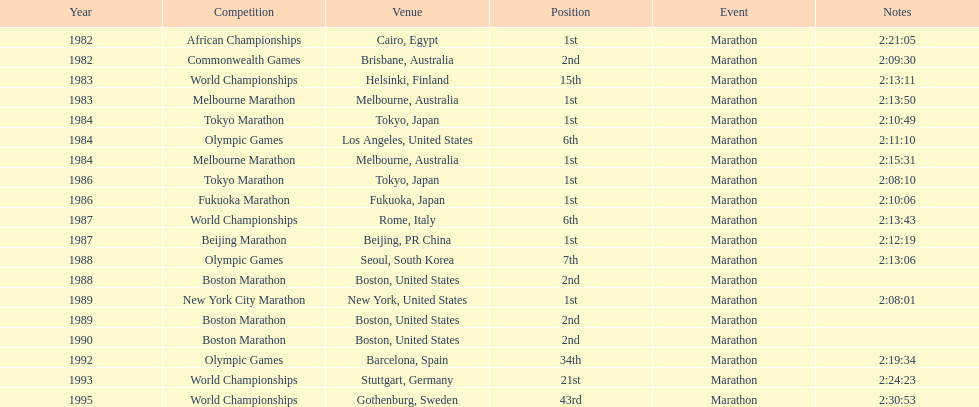Which competition is listed the most in this chart? World Championships. Could you parse the entire table? {'header': ['Year', 'Competition', 'Venue', 'Position', 'Event', 'Notes'], 'rows': [['1982', 'African Championships', 'Cairo, Egypt', '1st', 'Marathon', '2:21:05'], ['1982', 'Commonwealth Games', 'Brisbane, Australia', '2nd', 'Marathon', '2:09:30'], ['1983', 'World Championships', 'Helsinki, Finland', '15th', 'Marathon', '2:13:11'], ['1983', 'Melbourne Marathon', 'Melbourne, Australia', '1st', 'Marathon', '2:13:50'], ['1984', 'Tokyo Marathon', 'Tokyo, Japan', '1st', 'Marathon', '2:10:49'], ['1984', 'Olympic Games', 'Los Angeles, United States', '6th', 'Marathon', '2:11:10'], ['1984', 'Melbourne Marathon', 'Melbourne, Australia', '1st', 'Marathon', '2:15:31'], ['1986', 'Tokyo Marathon', 'Tokyo, Japan', '1st', 'Marathon', '2:08:10'], ['1986', 'Fukuoka Marathon', 'Fukuoka, Japan', '1st', 'Marathon', '2:10:06'], ['1987', 'World Championships', 'Rome, Italy', '6th', 'Marathon', '2:13:43'], ['1987', 'Beijing Marathon', 'Beijing, PR China', '1st', 'Marathon', '2:12:19'], ['1988', 'Olympic Games', 'Seoul, South Korea', '7th', 'Marathon', '2:13:06'], ['1988', 'Boston Marathon', 'Boston, United States', '2nd', 'Marathon', ''], ['1989', 'New York City Marathon', 'New York, United States', '1st', 'Marathon', '2:08:01'], ['1989', 'Boston Marathon', 'Boston, United States', '2nd', 'Marathon', ''], ['1990', 'Boston Marathon', 'Boston, United States', '2nd', 'Marathon', ''], ['1992', 'Olympic Games', 'Barcelona, Spain', '34th', 'Marathon', '2:19:34'], ['1993', 'World Championships', 'Stuttgart, Germany', '21st', 'Marathon', '2:24:23'], ['1995', 'World Championships', 'Gothenburg, Sweden', '43rd', 'Marathon', '2:30:53']]} 